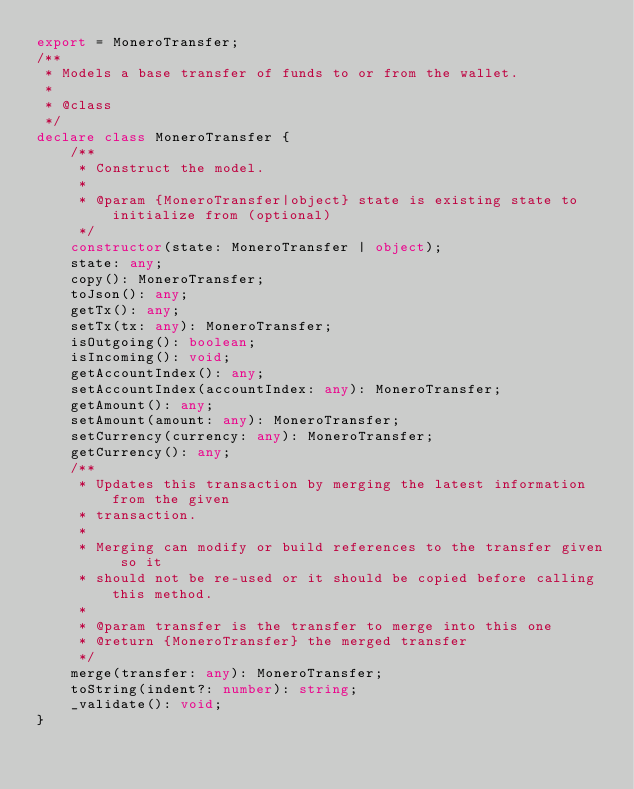Convert code to text. <code><loc_0><loc_0><loc_500><loc_500><_TypeScript_>export = MoneroTransfer;
/**
 * Models a base transfer of funds to or from the wallet.
 *
 * @class
 */
declare class MoneroTransfer {
    /**
     * Construct the model.
     *
     * @param {MoneroTransfer|object} state is existing state to initialize from (optional)
     */
    constructor(state: MoneroTransfer | object);
    state: any;
    copy(): MoneroTransfer;
    toJson(): any;
    getTx(): any;
    setTx(tx: any): MoneroTransfer;
    isOutgoing(): boolean;
    isIncoming(): void;
    getAccountIndex(): any;
    setAccountIndex(accountIndex: any): MoneroTransfer;
    getAmount(): any;
    setAmount(amount: any): MoneroTransfer;
    setCurrency(currency: any): MoneroTransfer;
    getCurrency(): any;
    /**
     * Updates this transaction by merging the latest information from the given
     * transaction.
     *
     * Merging can modify or build references to the transfer given so it
     * should not be re-used or it should be copied before calling this method.
     *
     * @param transfer is the transfer to merge into this one
     * @return {MoneroTransfer} the merged transfer
     */
    merge(transfer: any): MoneroTransfer;
    toString(indent?: number): string;
    _validate(): void;
}
</code> 